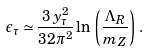Convert formula to latex. <formula><loc_0><loc_0><loc_500><loc_500>\epsilon _ { \tau } \simeq \frac { 3 \, y _ { \tau } ^ { 2 } } { 3 2 \pi ^ { 2 } } \ln \, \left ( \frac { \Lambda _ { R } } { m _ { Z } } \right ) \, .</formula> 